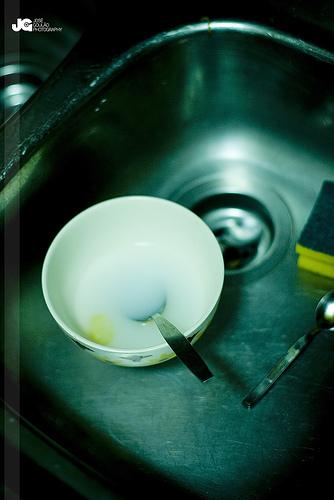Does the bowl have a flower pattern?
Be succinct. Yes. Are they cooking eggs?
Write a very short answer. No. What is in the sink?
Quick response, please. Bowl. Are both spoons immersed in liquid?
Be succinct. No. 